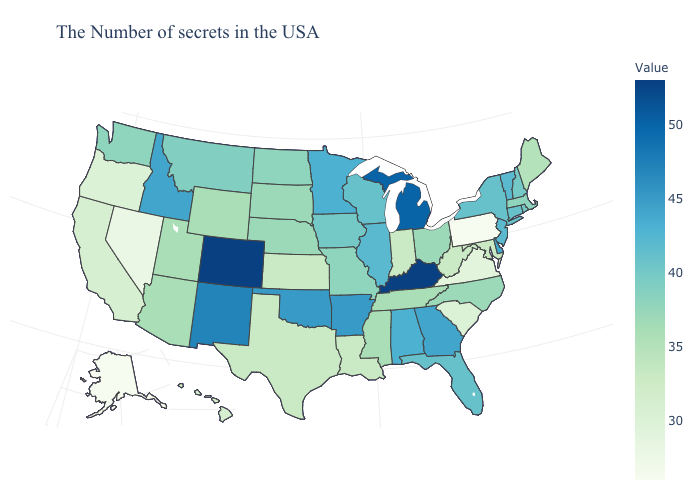Which states have the lowest value in the USA?
Give a very brief answer. Pennsylvania, Alaska. Does the map have missing data?
Concise answer only. No. Is the legend a continuous bar?
Answer briefly. Yes. Does Idaho have a lower value than New Mexico?
Short answer required. Yes. Does Colorado have the highest value in the USA?
Quick response, please. Yes. 